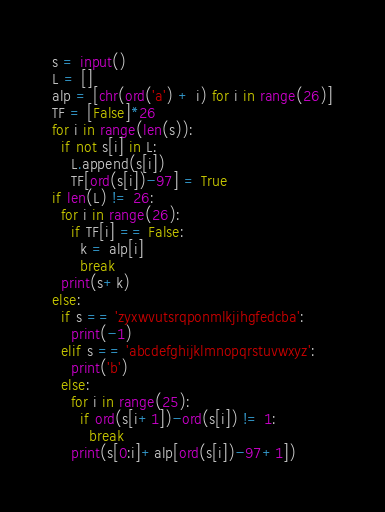<code> <loc_0><loc_0><loc_500><loc_500><_Python_>s = input()
L = []
alp = [chr(ord('a') + i) for i in range(26)]
TF = [False]*26
for i in range(len(s)):
  if not s[i] in L:
    L.append(s[i])
    TF[ord(s[i])-97] = True
if len(L) != 26:
  for i in range(26):
    if TF[i] == False:
      k = alp[i]
      break
  print(s+k)
else:
  if s == 'zyxwvutsrqponmlkjihgfedcba':
    print(-1)
  elif s == 'abcdefghijklmnopqrstuvwxyz':
    print('b')
  else:
    for i in range(25):
      if ord(s[i+1])-ord(s[i]) != 1:
        break
    print(s[0:i]+alp[ord(s[i])-97+1])</code> 